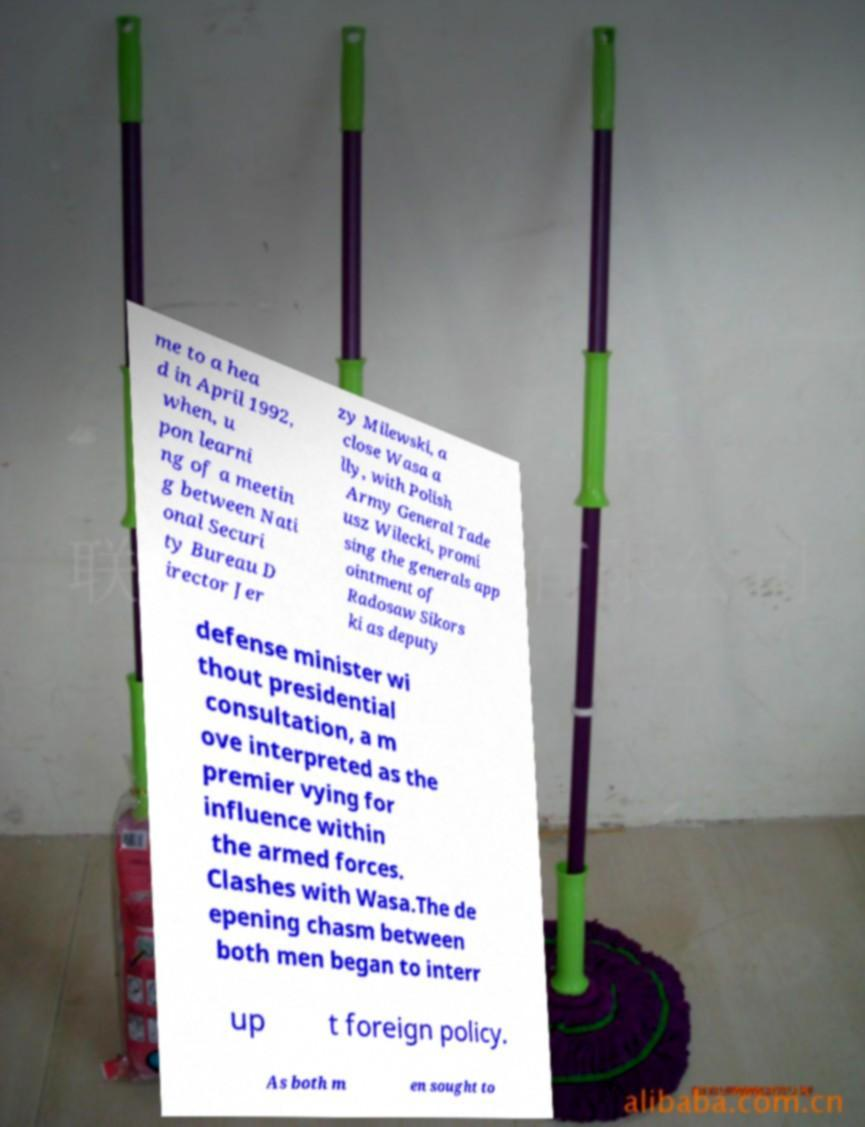Can you accurately transcribe the text from the provided image for me? me to a hea d in April 1992, when, u pon learni ng of a meetin g between Nati onal Securi ty Bureau D irector Jer zy Milewski, a close Wasa a lly, with Polish Army General Tade usz Wilecki, promi sing the generals app ointment of Radosaw Sikors ki as deputy defense minister wi thout presidential consultation, a m ove interpreted as the premier vying for influence within the armed forces. Clashes with Wasa.The de epening chasm between both men began to interr up t foreign policy. As both m en sought to 